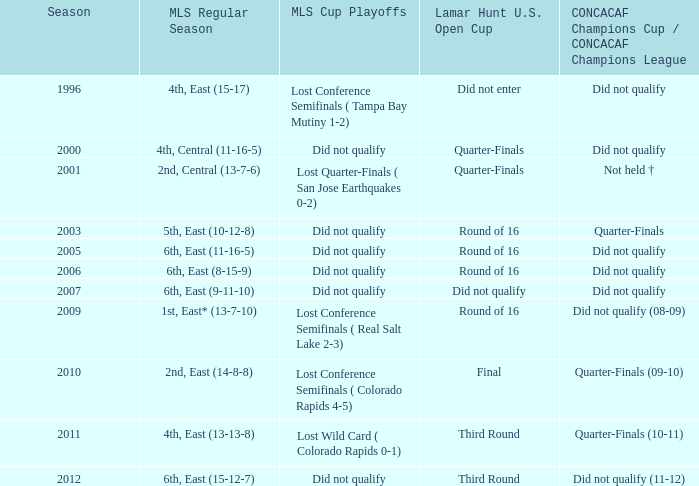What was the mls cup playoffs when the mls regular season was 4th, central (11-16-5)? Did not qualify. I'm looking to parse the entire table for insights. Could you assist me with that? {'header': ['Season', 'MLS Regular Season', 'MLS Cup Playoffs', 'Lamar Hunt U.S. Open Cup', 'CONCACAF Champions Cup / CONCACAF Champions League'], 'rows': [['1996', '4th, East (15-17)', 'Lost Conference Semifinals ( Tampa Bay Mutiny 1-2)', 'Did not enter', 'Did not qualify'], ['2000', '4th, Central (11-16-5)', 'Did not qualify', 'Quarter-Finals', 'Did not qualify'], ['2001', '2nd, Central (13-7-6)', 'Lost Quarter-Finals ( San Jose Earthquakes 0-2)', 'Quarter-Finals', 'Not held †'], ['2003', '5th, East (10-12-8)', 'Did not qualify', 'Round of 16', 'Quarter-Finals'], ['2005', '6th, East (11-16-5)', 'Did not qualify', 'Round of 16', 'Did not qualify'], ['2006', '6th, East (8-15-9)', 'Did not qualify', 'Round of 16', 'Did not qualify'], ['2007', '6th, East (9-11-10)', 'Did not qualify', 'Did not qualify', 'Did not qualify'], ['2009', '1st, East* (13-7-10)', 'Lost Conference Semifinals ( Real Salt Lake 2-3)', 'Round of 16', 'Did not qualify (08-09)'], ['2010', '2nd, East (14-8-8)', 'Lost Conference Semifinals ( Colorado Rapids 4-5)', 'Final', 'Quarter-Finals (09-10)'], ['2011', '4th, East (13-13-8)', 'Lost Wild Card ( Colorado Rapids 0-1)', 'Third Round', 'Quarter-Finals (10-11)'], ['2012', '6th, East (15-12-7)', 'Did not qualify', 'Third Round', 'Did not qualify (11-12)']]} 